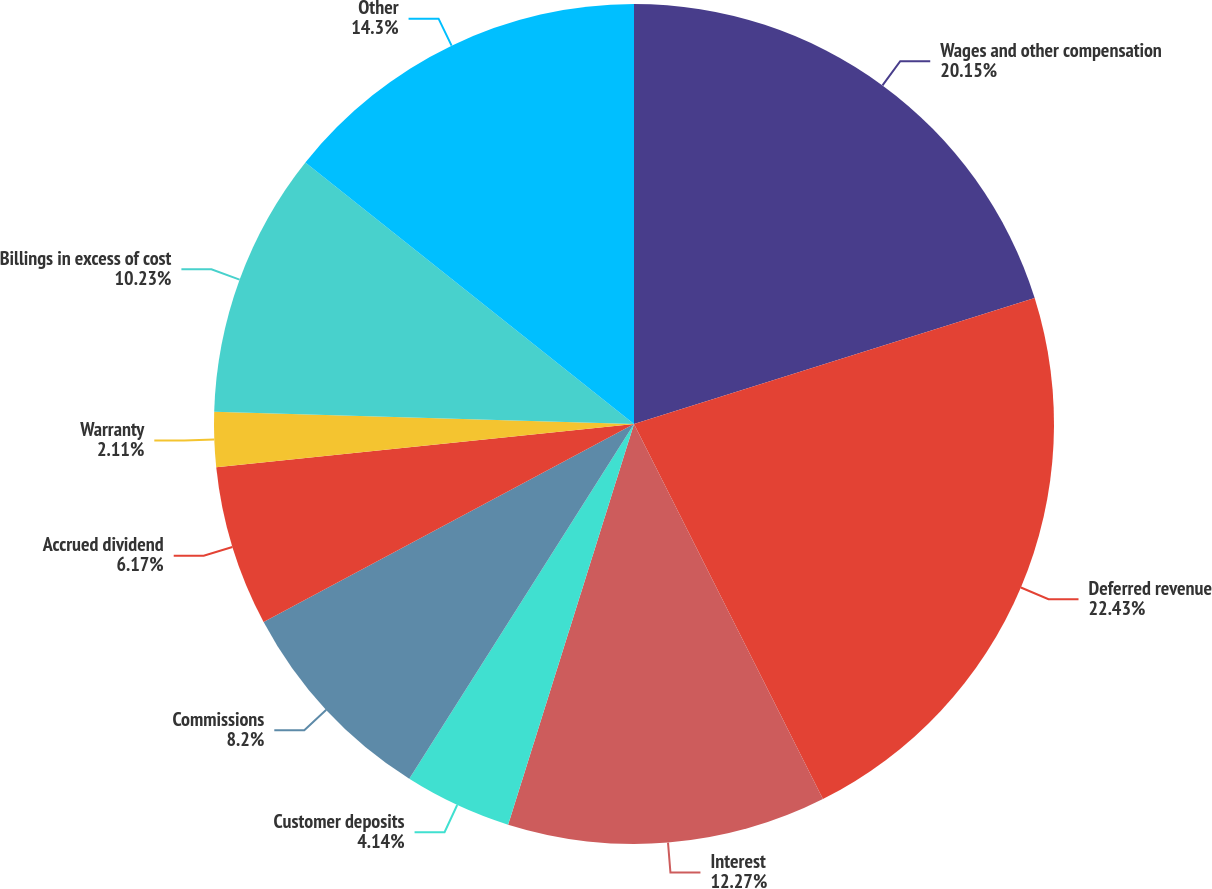Convert chart. <chart><loc_0><loc_0><loc_500><loc_500><pie_chart><fcel>Wages and other compensation<fcel>Deferred revenue<fcel>Interest<fcel>Customer deposits<fcel>Commissions<fcel>Accrued dividend<fcel>Warranty<fcel>Billings in excess of cost<fcel>Other<nl><fcel>20.15%<fcel>22.42%<fcel>12.27%<fcel>4.14%<fcel>8.2%<fcel>6.17%<fcel>2.11%<fcel>10.23%<fcel>14.3%<nl></chart> 